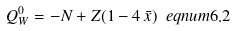Convert formula to latex. <formula><loc_0><loc_0><loc_500><loc_500>Q _ { W } ^ { 0 } = - N + Z ( 1 - 4 \, \bar { x } ) \ e q n u m { 6 . 2 }</formula> 